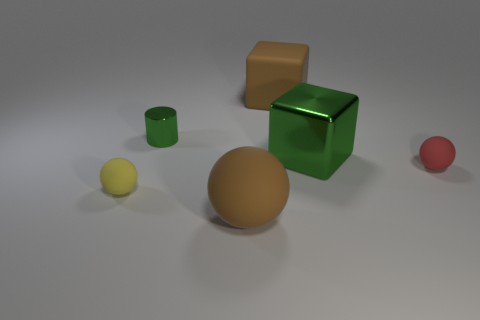Subtract all tiny red matte balls. How many balls are left? 2 Subtract all green cubes. How many cubes are left? 1 Subtract all cylinders. How many objects are left? 5 Add 2 large blocks. How many objects exist? 8 Subtract all yellow cylinders. Subtract all yellow blocks. How many cylinders are left? 1 Subtract all brown blocks. How many yellow balls are left? 1 Subtract all large brown matte balls. Subtract all spheres. How many objects are left? 2 Add 3 green metal cubes. How many green metal cubes are left? 4 Add 2 large purple metal spheres. How many large purple metal spheres exist? 2 Subtract 0 cyan blocks. How many objects are left? 6 